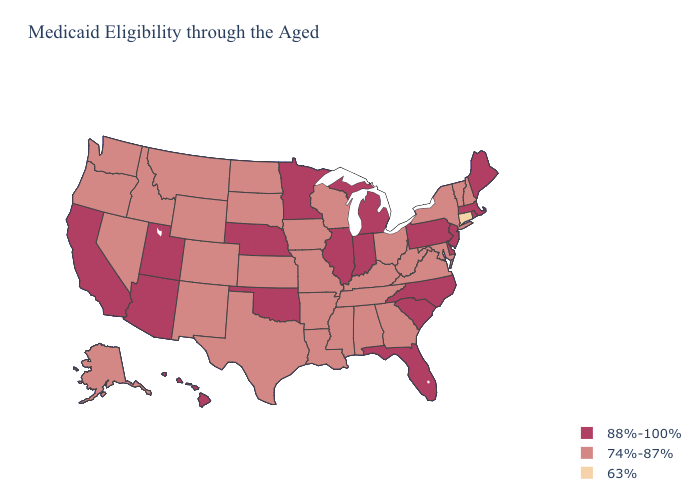Does the map have missing data?
Answer briefly. No. Among the states that border Mississippi , which have the lowest value?
Be succinct. Alabama, Arkansas, Louisiana, Tennessee. Among the states that border Nebraska , which have the lowest value?
Short answer required. Colorado, Iowa, Kansas, Missouri, South Dakota, Wyoming. Does South Carolina have the highest value in the South?
Answer briefly. Yes. Name the states that have a value in the range 88%-100%?
Concise answer only. Arizona, California, Delaware, Florida, Hawaii, Illinois, Indiana, Maine, Massachusetts, Michigan, Minnesota, Nebraska, New Jersey, North Carolina, Oklahoma, Pennsylvania, Rhode Island, South Carolina, Utah. What is the value of North Carolina?
Concise answer only. 88%-100%. What is the value of Washington?
Concise answer only. 74%-87%. What is the value of Kentucky?
Write a very short answer. 74%-87%. What is the value of Nevada?
Short answer required. 74%-87%. Does Louisiana have the same value as Tennessee?
Give a very brief answer. Yes. What is the value of California?
Write a very short answer. 88%-100%. What is the value of Connecticut?
Write a very short answer. 63%. What is the value of Georgia?
Write a very short answer. 74%-87%. What is the value of Pennsylvania?
Keep it brief. 88%-100%. What is the highest value in states that border Kentucky?
Be succinct. 88%-100%. 